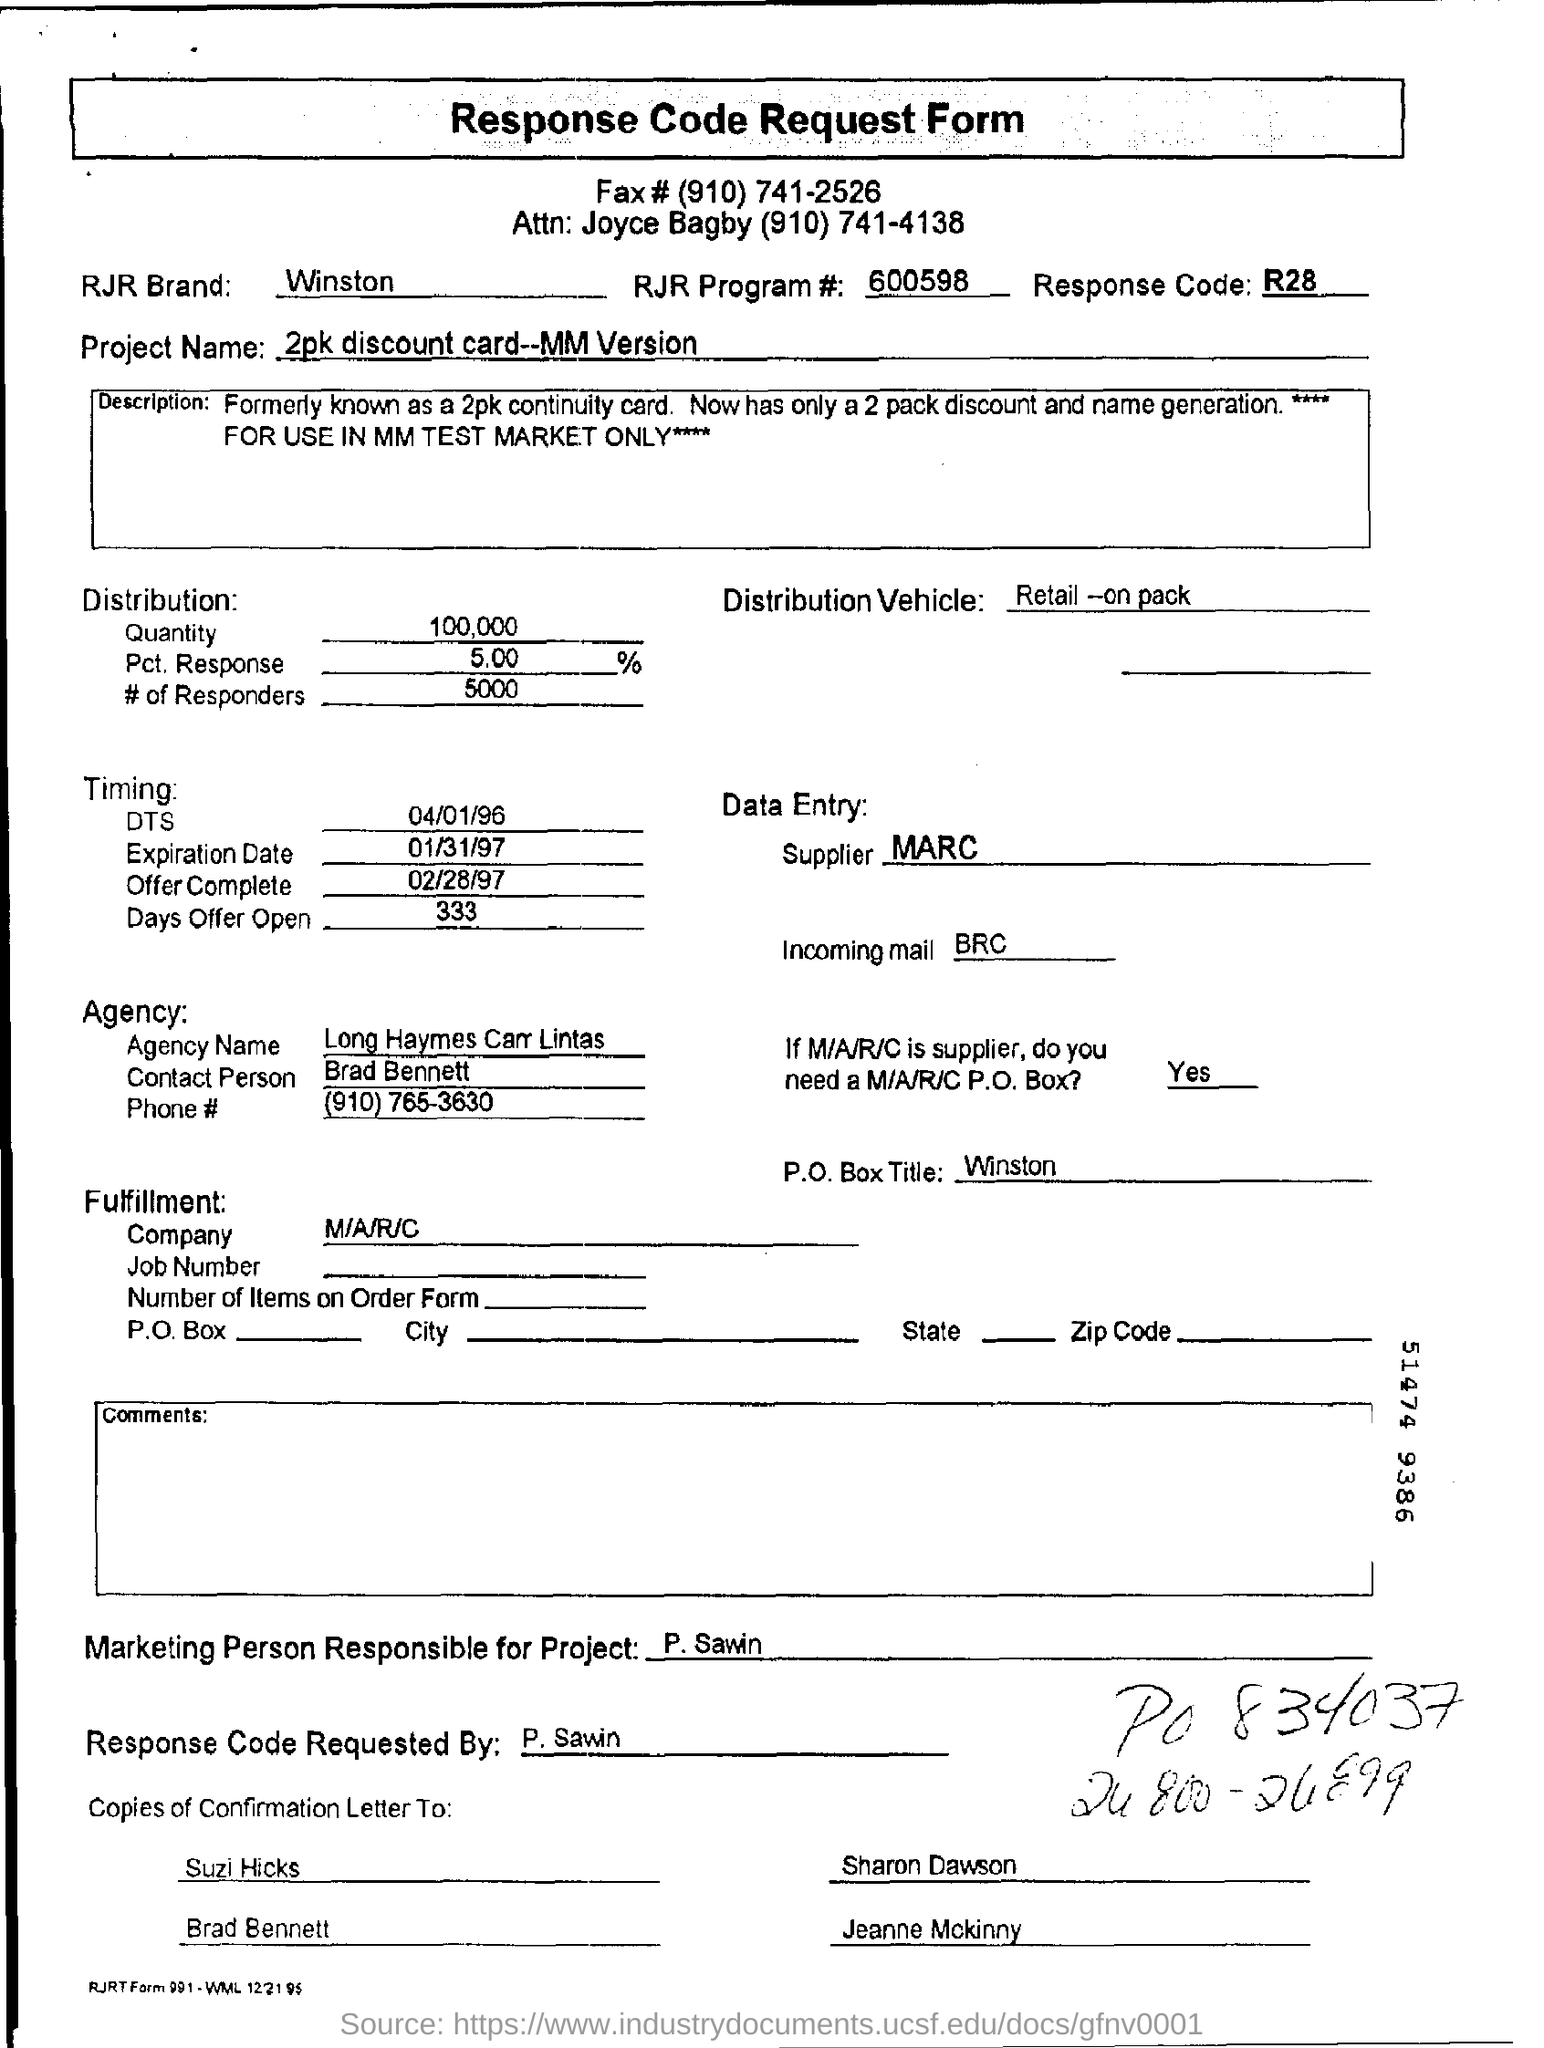What is the RJR Brand?
Provide a succinct answer. Winston. What is the RJR Program # ?
Offer a terse response. 600598. What is the response code mentioned in the form?
Your answer should be compact. R28. Who is the supplier?
Your response must be concise. MARC. What is the RJR Brand given in the form?
Ensure brevity in your answer.  Winston. What is the P. O. BOX Title?
Keep it short and to the point. Winston. The Response Code was requested by whom?
Make the answer very short. P. sawin. 